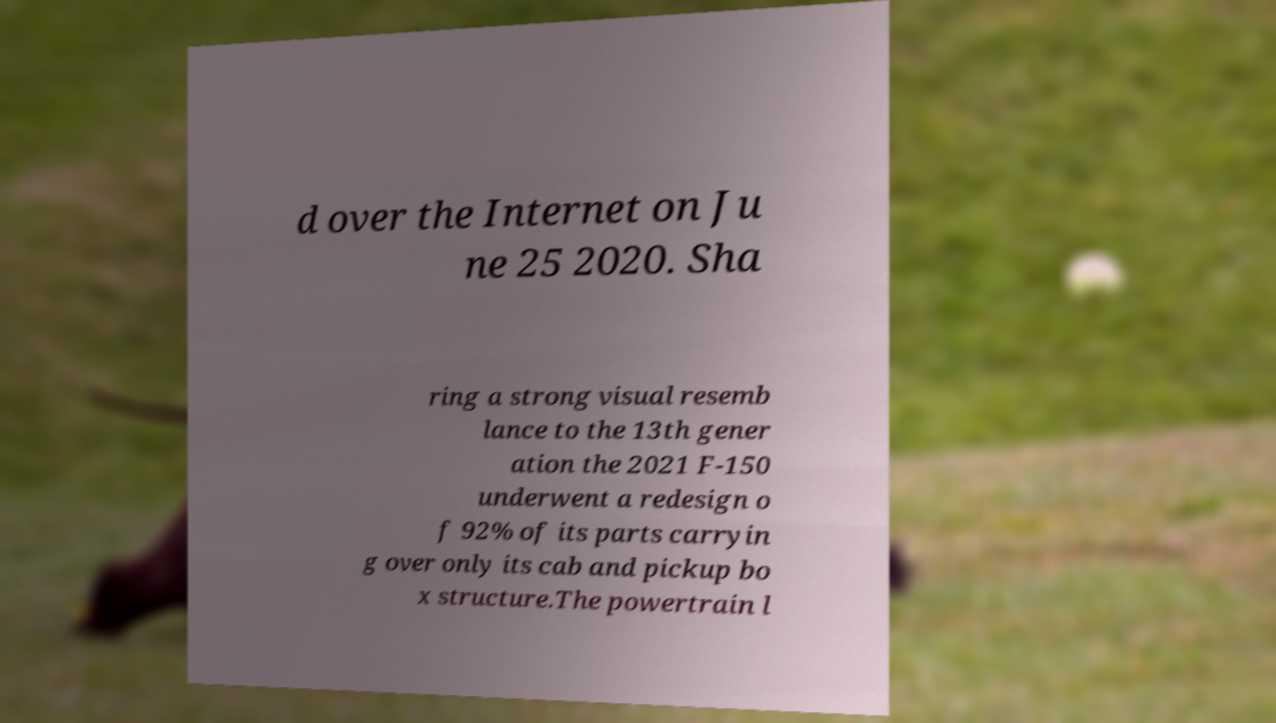What messages or text are displayed in this image? I need them in a readable, typed format. d over the Internet on Ju ne 25 2020. Sha ring a strong visual resemb lance to the 13th gener ation the 2021 F-150 underwent a redesign o f 92% of its parts carryin g over only its cab and pickup bo x structure.The powertrain l 